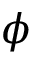<formula> <loc_0><loc_0><loc_500><loc_500>\phi</formula> 